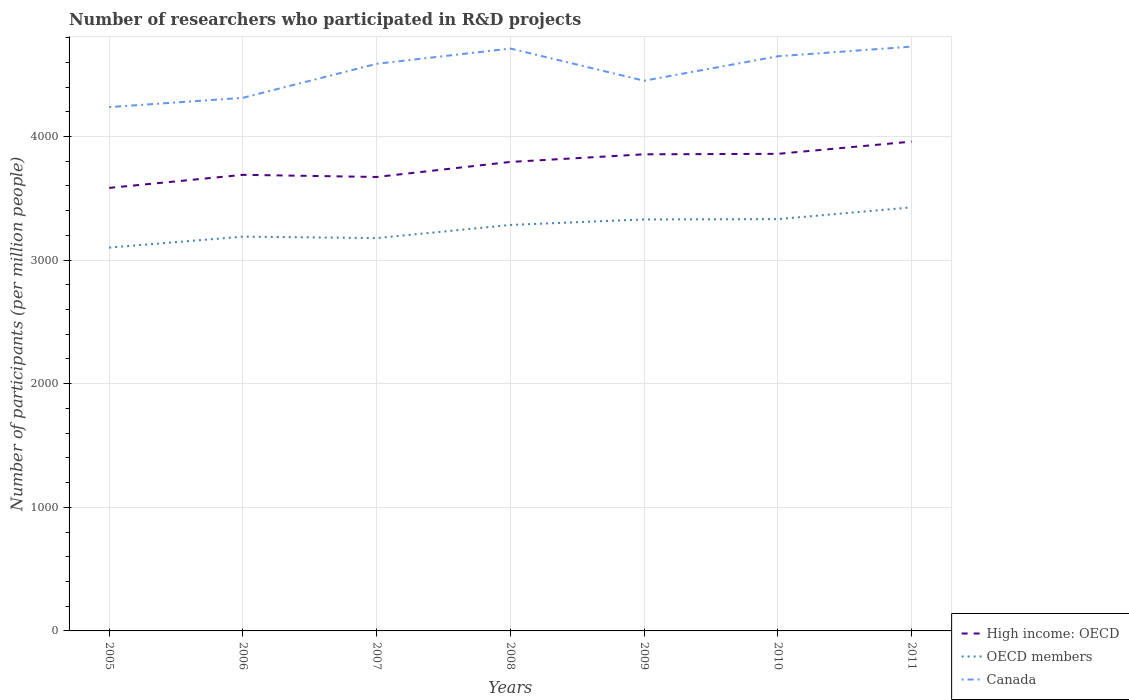How many different coloured lines are there?
Offer a very short reply. 3. Across all years, what is the maximum number of researchers who participated in R&D projects in High income: OECD?
Your answer should be very brief. 3584.25. What is the total number of researchers who participated in R&D projects in Canada in the graph?
Provide a succinct answer. -275.01. What is the difference between the highest and the second highest number of researchers who participated in R&D projects in High income: OECD?
Offer a very short reply. 374.47. What is the difference between the highest and the lowest number of researchers who participated in R&D projects in High income: OECD?
Ensure brevity in your answer.  4. Is the number of researchers who participated in R&D projects in High income: OECD strictly greater than the number of researchers who participated in R&D projects in OECD members over the years?
Provide a succinct answer. No. How many lines are there?
Provide a succinct answer. 3. Does the graph contain any zero values?
Keep it short and to the point. No. Does the graph contain grids?
Your answer should be very brief. Yes. Where does the legend appear in the graph?
Offer a very short reply. Bottom right. How many legend labels are there?
Keep it short and to the point. 3. How are the legend labels stacked?
Give a very brief answer. Vertical. What is the title of the graph?
Give a very brief answer. Number of researchers who participated in R&D projects. What is the label or title of the X-axis?
Make the answer very short. Years. What is the label or title of the Y-axis?
Your answer should be compact. Number of participants (per million people). What is the Number of participants (per million people) in High income: OECD in 2005?
Keep it short and to the point. 3584.25. What is the Number of participants (per million people) of OECD members in 2005?
Provide a short and direct response. 3101.32. What is the Number of participants (per million people) in Canada in 2005?
Provide a short and direct response. 4237.93. What is the Number of participants (per million people) in High income: OECD in 2006?
Your response must be concise. 3690.04. What is the Number of participants (per million people) of OECD members in 2006?
Your answer should be very brief. 3189.88. What is the Number of participants (per million people) of Canada in 2006?
Provide a short and direct response. 4313.21. What is the Number of participants (per million people) of High income: OECD in 2007?
Provide a short and direct response. 3672.63. What is the Number of participants (per million people) of OECD members in 2007?
Give a very brief answer. 3178.1. What is the Number of participants (per million people) of Canada in 2007?
Keep it short and to the point. 4588.22. What is the Number of participants (per million people) of High income: OECD in 2008?
Provide a succinct answer. 3794.36. What is the Number of participants (per million people) of OECD members in 2008?
Ensure brevity in your answer.  3284.49. What is the Number of participants (per million people) in Canada in 2008?
Ensure brevity in your answer.  4711.77. What is the Number of participants (per million people) of High income: OECD in 2009?
Offer a very short reply. 3856. What is the Number of participants (per million people) of OECD members in 2009?
Give a very brief answer. 3329.07. What is the Number of participants (per million people) in Canada in 2009?
Give a very brief answer. 4451.42. What is the Number of participants (per million people) of High income: OECD in 2010?
Offer a very short reply. 3859.78. What is the Number of participants (per million people) in OECD members in 2010?
Give a very brief answer. 3331.63. What is the Number of participants (per million people) of Canada in 2010?
Ensure brevity in your answer.  4649.22. What is the Number of participants (per million people) in High income: OECD in 2011?
Your answer should be compact. 3958.72. What is the Number of participants (per million people) of OECD members in 2011?
Provide a short and direct response. 3426.85. What is the Number of participants (per million people) of Canada in 2011?
Provide a short and direct response. 4727.26. Across all years, what is the maximum Number of participants (per million people) in High income: OECD?
Keep it short and to the point. 3958.72. Across all years, what is the maximum Number of participants (per million people) of OECD members?
Keep it short and to the point. 3426.85. Across all years, what is the maximum Number of participants (per million people) of Canada?
Your response must be concise. 4727.26. Across all years, what is the minimum Number of participants (per million people) of High income: OECD?
Your response must be concise. 3584.25. Across all years, what is the minimum Number of participants (per million people) in OECD members?
Your response must be concise. 3101.32. Across all years, what is the minimum Number of participants (per million people) of Canada?
Provide a succinct answer. 4237.93. What is the total Number of participants (per million people) in High income: OECD in the graph?
Ensure brevity in your answer.  2.64e+04. What is the total Number of participants (per million people) in OECD members in the graph?
Offer a very short reply. 2.28e+04. What is the total Number of participants (per million people) in Canada in the graph?
Keep it short and to the point. 3.17e+04. What is the difference between the Number of participants (per million people) of High income: OECD in 2005 and that in 2006?
Ensure brevity in your answer.  -105.79. What is the difference between the Number of participants (per million people) in OECD members in 2005 and that in 2006?
Ensure brevity in your answer.  -88.56. What is the difference between the Number of participants (per million people) in Canada in 2005 and that in 2006?
Ensure brevity in your answer.  -75.28. What is the difference between the Number of participants (per million people) of High income: OECD in 2005 and that in 2007?
Offer a terse response. -88.38. What is the difference between the Number of participants (per million people) in OECD members in 2005 and that in 2007?
Give a very brief answer. -76.77. What is the difference between the Number of participants (per million people) in Canada in 2005 and that in 2007?
Your response must be concise. -350.29. What is the difference between the Number of participants (per million people) in High income: OECD in 2005 and that in 2008?
Give a very brief answer. -210.11. What is the difference between the Number of participants (per million people) of OECD members in 2005 and that in 2008?
Ensure brevity in your answer.  -183.16. What is the difference between the Number of participants (per million people) of Canada in 2005 and that in 2008?
Offer a very short reply. -473.84. What is the difference between the Number of participants (per million people) of High income: OECD in 2005 and that in 2009?
Give a very brief answer. -271.75. What is the difference between the Number of participants (per million people) of OECD members in 2005 and that in 2009?
Offer a very short reply. -227.74. What is the difference between the Number of participants (per million people) in Canada in 2005 and that in 2009?
Your answer should be compact. -213.49. What is the difference between the Number of participants (per million people) in High income: OECD in 2005 and that in 2010?
Provide a short and direct response. -275.53. What is the difference between the Number of participants (per million people) in OECD members in 2005 and that in 2010?
Make the answer very short. -230.3. What is the difference between the Number of participants (per million people) in Canada in 2005 and that in 2010?
Make the answer very short. -411.29. What is the difference between the Number of participants (per million people) of High income: OECD in 2005 and that in 2011?
Your answer should be very brief. -374.47. What is the difference between the Number of participants (per million people) of OECD members in 2005 and that in 2011?
Keep it short and to the point. -325.53. What is the difference between the Number of participants (per million people) of Canada in 2005 and that in 2011?
Provide a short and direct response. -489.33. What is the difference between the Number of participants (per million people) in High income: OECD in 2006 and that in 2007?
Make the answer very short. 17.41. What is the difference between the Number of participants (per million people) of OECD members in 2006 and that in 2007?
Provide a succinct answer. 11.78. What is the difference between the Number of participants (per million people) of Canada in 2006 and that in 2007?
Give a very brief answer. -275.01. What is the difference between the Number of participants (per million people) in High income: OECD in 2006 and that in 2008?
Give a very brief answer. -104.32. What is the difference between the Number of participants (per million people) of OECD members in 2006 and that in 2008?
Make the answer very short. -94.6. What is the difference between the Number of participants (per million people) in Canada in 2006 and that in 2008?
Ensure brevity in your answer.  -398.56. What is the difference between the Number of participants (per million people) of High income: OECD in 2006 and that in 2009?
Give a very brief answer. -165.96. What is the difference between the Number of participants (per million people) in OECD members in 2006 and that in 2009?
Offer a very short reply. -139.18. What is the difference between the Number of participants (per million people) of Canada in 2006 and that in 2009?
Ensure brevity in your answer.  -138.21. What is the difference between the Number of participants (per million people) in High income: OECD in 2006 and that in 2010?
Provide a short and direct response. -169.74. What is the difference between the Number of participants (per million people) in OECD members in 2006 and that in 2010?
Offer a very short reply. -141.75. What is the difference between the Number of participants (per million people) in Canada in 2006 and that in 2010?
Your answer should be very brief. -336.01. What is the difference between the Number of participants (per million people) of High income: OECD in 2006 and that in 2011?
Your answer should be compact. -268.68. What is the difference between the Number of participants (per million people) of OECD members in 2006 and that in 2011?
Provide a succinct answer. -236.97. What is the difference between the Number of participants (per million people) of Canada in 2006 and that in 2011?
Your response must be concise. -414.05. What is the difference between the Number of participants (per million people) in High income: OECD in 2007 and that in 2008?
Give a very brief answer. -121.73. What is the difference between the Number of participants (per million people) in OECD members in 2007 and that in 2008?
Provide a succinct answer. -106.39. What is the difference between the Number of participants (per million people) of Canada in 2007 and that in 2008?
Ensure brevity in your answer.  -123.55. What is the difference between the Number of participants (per million people) of High income: OECD in 2007 and that in 2009?
Provide a short and direct response. -183.37. What is the difference between the Number of participants (per million people) in OECD members in 2007 and that in 2009?
Offer a terse response. -150.97. What is the difference between the Number of participants (per million people) in Canada in 2007 and that in 2009?
Your response must be concise. 136.81. What is the difference between the Number of participants (per million people) of High income: OECD in 2007 and that in 2010?
Your answer should be compact. -187.15. What is the difference between the Number of participants (per million people) in OECD members in 2007 and that in 2010?
Offer a terse response. -153.53. What is the difference between the Number of participants (per million people) in Canada in 2007 and that in 2010?
Give a very brief answer. -61. What is the difference between the Number of participants (per million people) in High income: OECD in 2007 and that in 2011?
Provide a succinct answer. -286.09. What is the difference between the Number of participants (per million people) in OECD members in 2007 and that in 2011?
Provide a succinct answer. -248.75. What is the difference between the Number of participants (per million people) in Canada in 2007 and that in 2011?
Give a very brief answer. -139.04. What is the difference between the Number of participants (per million people) in High income: OECD in 2008 and that in 2009?
Offer a very short reply. -61.64. What is the difference between the Number of participants (per million people) of OECD members in 2008 and that in 2009?
Ensure brevity in your answer.  -44.58. What is the difference between the Number of participants (per million people) in Canada in 2008 and that in 2009?
Your response must be concise. 260.35. What is the difference between the Number of participants (per million people) of High income: OECD in 2008 and that in 2010?
Your answer should be very brief. -65.42. What is the difference between the Number of participants (per million people) of OECD members in 2008 and that in 2010?
Your answer should be very brief. -47.14. What is the difference between the Number of participants (per million people) in Canada in 2008 and that in 2010?
Offer a very short reply. 62.55. What is the difference between the Number of participants (per million people) in High income: OECD in 2008 and that in 2011?
Offer a terse response. -164.36. What is the difference between the Number of participants (per million people) of OECD members in 2008 and that in 2011?
Offer a very short reply. -142.36. What is the difference between the Number of participants (per million people) in Canada in 2008 and that in 2011?
Ensure brevity in your answer.  -15.49. What is the difference between the Number of participants (per million people) of High income: OECD in 2009 and that in 2010?
Ensure brevity in your answer.  -3.78. What is the difference between the Number of participants (per million people) in OECD members in 2009 and that in 2010?
Provide a succinct answer. -2.56. What is the difference between the Number of participants (per million people) of Canada in 2009 and that in 2010?
Offer a terse response. -197.8. What is the difference between the Number of participants (per million people) in High income: OECD in 2009 and that in 2011?
Provide a succinct answer. -102.72. What is the difference between the Number of participants (per million people) of OECD members in 2009 and that in 2011?
Your answer should be compact. -97.79. What is the difference between the Number of participants (per million people) of Canada in 2009 and that in 2011?
Your answer should be compact. -275.84. What is the difference between the Number of participants (per million people) in High income: OECD in 2010 and that in 2011?
Ensure brevity in your answer.  -98.94. What is the difference between the Number of participants (per million people) in OECD members in 2010 and that in 2011?
Give a very brief answer. -95.22. What is the difference between the Number of participants (per million people) of Canada in 2010 and that in 2011?
Provide a short and direct response. -78.04. What is the difference between the Number of participants (per million people) in High income: OECD in 2005 and the Number of participants (per million people) in OECD members in 2006?
Your answer should be very brief. 394.37. What is the difference between the Number of participants (per million people) of High income: OECD in 2005 and the Number of participants (per million people) of Canada in 2006?
Offer a very short reply. -728.96. What is the difference between the Number of participants (per million people) of OECD members in 2005 and the Number of participants (per million people) of Canada in 2006?
Give a very brief answer. -1211.89. What is the difference between the Number of participants (per million people) of High income: OECD in 2005 and the Number of participants (per million people) of OECD members in 2007?
Your answer should be compact. 406.15. What is the difference between the Number of participants (per million people) in High income: OECD in 2005 and the Number of participants (per million people) in Canada in 2007?
Provide a short and direct response. -1003.97. What is the difference between the Number of participants (per million people) in OECD members in 2005 and the Number of participants (per million people) in Canada in 2007?
Offer a terse response. -1486.9. What is the difference between the Number of participants (per million people) in High income: OECD in 2005 and the Number of participants (per million people) in OECD members in 2008?
Ensure brevity in your answer.  299.76. What is the difference between the Number of participants (per million people) of High income: OECD in 2005 and the Number of participants (per million people) of Canada in 2008?
Provide a short and direct response. -1127.52. What is the difference between the Number of participants (per million people) of OECD members in 2005 and the Number of participants (per million people) of Canada in 2008?
Your answer should be very brief. -1610.45. What is the difference between the Number of participants (per million people) of High income: OECD in 2005 and the Number of participants (per million people) of OECD members in 2009?
Keep it short and to the point. 255.18. What is the difference between the Number of participants (per million people) of High income: OECD in 2005 and the Number of participants (per million people) of Canada in 2009?
Ensure brevity in your answer.  -867.17. What is the difference between the Number of participants (per million people) in OECD members in 2005 and the Number of participants (per million people) in Canada in 2009?
Offer a terse response. -1350.09. What is the difference between the Number of participants (per million people) of High income: OECD in 2005 and the Number of participants (per million people) of OECD members in 2010?
Provide a short and direct response. 252.62. What is the difference between the Number of participants (per million people) in High income: OECD in 2005 and the Number of participants (per million people) in Canada in 2010?
Give a very brief answer. -1064.97. What is the difference between the Number of participants (per million people) of OECD members in 2005 and the Number of participants (per million people) of Canada in 2010?
Your answer should be compact. -1547.89. What is the difference between the Number of participants (per million people) of High income: OECD in 2005 and the Number of participants (per million people) of OECD members in 2011?
Ensure brevity in your answer.  157.4. What is the difference between the Number of participants (per million people) of High income: OECD in 2005 and the Number of participants (per million people) of Canada in 2011?
Your response must be concise. -1143.01. What is the difference between the Number of participants (per million people) in OECD members in 2005 and the Number of participants (per million people) in Canada in 2011?
Give a very brief answer. -1625.94. What is the difference between the Number of participants (per million people) of High income: OECD in 2006 and the Number of participants (per million people) of OECD members in 2007?
Provide a succinct answer. 511.94. What is the difference between the Number of participants (per million people) of High income: OECD in 2006 and the Number of participants (per million people) of Canada in 2007?
Your answer should be compact. -898.18. What is the difference between the Number of participants (per million people) in OECD members in 2006 and the Number of participants (per million people) in Canada in 2007?
Keep it short and to the point. -1398.34. What is the difference between the Number of participants (per million people) in High income: OECD in 2006 and the Number of participants (per million people) in OECD members in 2008?
Provide a succinct answer. 405.55. What is the difference between the Number of participants (per million people) in High income: OECD in 2006 and the Number of participants (per million people) in Canada in 2008?
Keep it short and to the point. -1021.73. What is the difference between the Number of participants (per million people) of OECD members in 2006 and the Number of participants (per million people) of Canada in 2008?
Your answer should be compact. -1521.89. What is the difference between the Number of participants (per million people) of High income: OECD in 2006 and the Number of participants (per million people) of OECD members in 2009?
Provide a short and direct response. 360.98. What is the difference between the Number of participants (per million people) in High income: OECD in 2006 and the Number of participants (per million people) in Canada in 2009?
Make the answer very short. -761.37. What is the difference between the Number of participants (per million people) of OECD members in 2006 and the Number of participants (per million people) of Canada in 2009?
Provide a short and direct response. -1261.53. What is the difference between the Number of participants (per million people) of High income: OECD in 2006 and the Number of participants (per million people) of OECD members in 2010?
Give a very brief answer. 358.41. What is the difference between the Number of participants (per million people) in High income: OECD in 2006 and the Number of participants (per million people) in Canada in 2010?
Provide a succinct answer. -959.18. What is the difference between the Number of participants (per million people) in OECD members in 2006 and the Number of participants (per million people) in Canada in 2010?
Ensure brevity in your answer.  -1459.33. What is the difference between the Number of participants (per million people) of High income: OECD in 2006 and the Number of participants (per million people) of OECD members in 2011?
Your response must be concise. 263.19. What is the difference between the Number of participants (per million people) in High income: OECD in 2006 and the Number of participants (per million people) in Canada in 2011?
Your answer should be compact. -1037.22. What is the difference between the Number of participants (per million people) in OECD members in 2006 and the Number of participants (per million people) in Canada in 2011?
Provide a short and direct response. -1537.38. What is the difference between the Number of participants (per million people) in High income: OECD in 2007 and the Number of participants (per million people) in OECD members in 2008?
Offer a terse response. 388.15. What is the difference between the Number of participants (per million people) in High income: OECD in 2007 and the Number of participants (per million people) in Canada in 2008?
Offer a very short reply. -1039.14. What is the difference between the Number of participants (per million people) of OECD members in 2007 and the Number of participants (per million people) of Canada in 2008?
Keep it short and to the point. -1533.67. What is the difference between the Number of participants (per million people) of High income: OECD in 2007 and the Number of participants (per million people) of OECD members in 2009?
Make the answer very short. 343.57. What is the difference between the Number of participants (per million people) in High income: OECD in 2007 and the Number of participants (per million people) in Canada in 2009?
Ensure brevity in your answer.  -778.78. What is the difference between the Number of participants (per million people) in OECD members in 2007 and the Number of participants (per million people) in Canada in 2009?
Your answer should be compact. -1273.32. What is the difference between the Number of participants (per million people) in High income: OECD in 2007 and the Number of participants (per million people) in OECD members in 2010?
Offer a terse response. 341. What is the difference between the Number of participants (per million people) of High income: OECD in 2007 and the Number of participants (per million people) of Canada in 2010?
Your answer should be very brief. -976.58. What is the difference between the Number of participants (per million people) of OECD members in 2007 and the Number of participants (per million people) of Canada in 2010?
Your response must be concise. -1471.12. What is the difference between the Number of participants (per million people) of High income: OECD in 2007 and the Number of participants (per million people) of OECD members in 2011?
Give a very brief answer. 245.78. What is the difference between the Number of participants (per million people) in High income: OECD in 2007 and the Number of participants (per million people) in Canada in 2011?
Provide a short and direct response. -1054.63. What is the difference between the Number of participants (per million people) in OECD members in 2007 and the Number of participants (per million people) in Canada in 2011?
Provide a short and direct response. -1549.16. What is the difference between the Number of participants (per million people) of High income: OECD in 2008 and the Number of participants (per million people) of OECD members in 2009?
Make the answer very short. 465.29. What is the difference between the Number of participants (per million people) in High income: OECD in 2008 and the Number of participants (per million people) in Canada in 2009?
Provide a short and direct response. -657.06. What is the difference between the Number of participants (per million people) of OECD members in 2008 and the Number of participants (per million people) of Canada in 2009?
Your answer should be very brief. -1166.93. What is the difference between the Number of participants (per million people) in High income: OECD in 2008 and the Number of participants (per million people) in OECD members in 2010?
Make the answer very short. 462.73. What is the difference between the Number of participants (per million people) in High income: OECD in 2008 and the Number of participants (per million people) in Canada in 2010?
Make the answer very short. -854.86. What is the difference between the Number of participants (per million people) of OECD members in 2008 and the Number of participants (per million people) of Canada in 2010?
Your response must be concise. -1364.73. What is the difference between the Number of participants (per million people) in High income: OECD in 2008 and the Number of participants (per million people) in OECD members in 2011?
Make the answer very short. 367.51. What is the difference between the Number of participants (per million people) of High income: OECD in 2008 and the Number of participants (per million people) of Canada in 2011?
Your response must be concise. -932.9. What is the difference between the Number of participants (per million people) of OECD members in 2008 and the Number of participants (per million people) of Canada in 2011?
Make the answer very short. -1442.77. What is the difference between the Number of participants (per million people) in High income: OECD in 2009 and the Number of participants (per million people) in OECD members in 2010?
Ensure brevity in your answer.  524.37. What is the difference between the Number of participants (per million people) of High income: OECD in 2009 and the Number of participants (per million people) of Canada in 2010?
Make the answer very short. -793.22. What is the difference between the Number of participants (per million people) of OECD members in 2009 and the Number of participants (per million people) of Canada in 2010?
Offer a very short reply. -1320.15. What is the difference between the Number of participants (per million people) of High income: OECD in 2009 and the Number of participants (per million people) of OECD members in 2011?
Provide a short and direct response. 429.15. What is the difference between the Number of participants (per million people) of High income: OECD in 2009 and the Number of participants (per million people) of Canada in 2011?
Keep it short and to the point. -871.26. What is the difference between the Number of participants (per million people) of OECD members in 2009 and the Number of participants (per million people) of Canada in 2011?
Provide a succinct answer. -1398.19. What is the difference between the Number of participants (per million people) of High income: OECD in 2010 and the Number of participants (per million people) of OECD members in 2011?
Your response must be concise. 432.93. What is the difference between the Number of participants (per million people) of High income: OECD in 2010 and the Number of participants (per million people) of Canada in 2011?
Give a very brief answer. -867.48. What is the difference between the Number of participants (per million people) in OECD members in 2010 and the Number of participants (per million people) in Canada in 2011?
Keep it short and to the point. -1395.63. What is the average Number of participants (per million people) of High income: OECD per year?
Offer a very short reply. 3773.68. What is the average Number of participants (per million people) of OECD members per year?
Offer a very short reply. 3263.05. What is the average Number of participants (per million people) of Canada per year?
Provide a succinct answer. 4525.57. In the year 2005, what is the difference between the Number of participants (per million people) of High income: OECD and Number of participants (per million people) of OECD members?
Give a very brief answer. 482.92. In the year 2005, what is the difference between the Number of participants (per million people) in High income: OECD and Number of participants (per million people) in Canada?
Make the answer very short. -653.68. In the year 2005, what is the difference between the Number of participants (per million people) in OECD members and Number of participants (per million people) in Canada?
Provide a short and direct response. -1136.6. In the year 2006, what is the difference between the Number of participants (per million people) of High income: OECD and Number of participants (per million people) of OECD members?
Make the answer very short. 500.16. In the year 2006, what is the difference between the Number of participants (per million people) of High income: OECD and Number of participants (per million people) of Canada?
Give a very brief answer. -623.17. In the year 2006, what is the difference between the Number of participants (per million people) of OECD members and Number of participants (per million people) of Canada?
Offer a very short reply. -1123.33. In the year 2007, what is the difference between the Number of participants (per million people) of High income: OECD and Number of participants (per million people) of OECD members?
Your answer should be very brief. 494.53. In the year 2007, what is the difference between the Number of participants (per million people) of High income: OECD and Number of participants (per million people) of Canada?
Your answer should be very brief. -915.59. In the year 2007, what is the difference between the Number of participants (per million people) of OECD members and Number of participants (per million people) of Canada?
Provide a short and direct response. -1410.12. In the year 2008, what is the difference between the Number of participants (per million people) of High income: OECD and Number of participants (per million people) of OECD members?
Your answer should be compact. 509.87. In the year 2008, what is the difference between the Number of participants (per million people) of High income: OECD and Number of participants (per million people) of Canada?
Provide a short and direct response. -917.41. In the year 2008, what is the difference between the Number of participants (per million people) of OECD members and Number of participants (per million people) of Canada?
Ensure brevity in your answer.  -1427.28. In the year 2009, what is the difference between the Number of participants (per million people) of High income: OECD and Number of participants (per million people) of OECD members?
Your response must be concise. 526.94. In the year 2009, what is the difference between the Number of participants (per million people) in High income: OECD and Number of participants (per million people) in Canada?
Provide a succinct answer. -595.42. In the year 2009, what is the difference between the Number of participants (per million people) of OECD members and Number of participants (per million people) of Canada?
Provide a short and direct response. -1122.35. In the year 2010, what is the difference between the Number of participants (per million people) of High income: OECD and Number of participants (per million people) of OECD members?
Make the answer very short. 528.15. In the year 2010, what is the difference between the Number of participants (per million people) in High income: OECD and Number of participants (per million people) in Canada?
Provide a short and direct response. -789.44. In the year 2010, what is the difference between the Number of participants (per million people) in OECD members and Number of participants (per million people) in Canada?
Make the answer very short. -1317.59. In the year 2011, what is the difference between the Number of participants (per million people) in High income: OECD and Number of participants (per million people) in OECD members?
Offer a very short reply. 531.87. In the year 2011, what is the difference between the Number of participants (per million people) in High income: OECD and Number of participants (per million people) in Canada?
Give a very brief answer. -768.54. In the year 2011, what is the difference between the Number of participants (per million people) of OECD members and Number of participants (per million people) of Canada?
Your response must be concise. -1300.41. What is the ratio of the Number of participants (per million people) in High income: OECD in 2005 to that in 2006?
Your response must be concise. 0.97. What is the ratio of the Number of participants (per million people) of OECD members in 2005 to that in 2006?
Provide a succinct answer. 0.97. What is the ratio of the Number of participants (per million people) in Canada in 2005 to that in 2006?
Your answer should be very brief. 0.98. What is the ratio of the Number of participants (per million people) of High income: OECD in 2005 to that in 2007?
Give a very brief answer. 0.98. What is the ratio of the Number of participants (per million people) of OECD members in 2005 to that in 2007?
Your answer should be compact. 0.98. What is the ratio of the Number of participants (per million people) of Canada in 2005 to that in 2007?
Provide a succinct answer. 0.92. What is the ratio of the Number of participants (per million people) in High income: OECD in 2005 to that in 2008?
Offer a very short reply. 0.94. What is the ratio of the Number of participants (per million people) of OECD members in 2005 to that in 2008?
Ensure brevity in your answer.  0.94. What is the ratio of the Number of participants (per million people) of Canada in 2005 to that in 2008?
Keep it short and to the point. 0.9. What is the ratio of the Number of participants (per million people) in High income: OECD in 2005 to that in 2009?
Keep it short and to the point. 0.93. What is the ratio of the Number of participants (per million people) in OECD members in 2005 to that in 2009?
Your response must be concise. 0.93. What is the ratio of the Number of participants (per million people) in High income: OECD in 2005 to that in 2010?
Offer a very short reply. 0.93. What is the ratio of the Number of participants (per million people) of OECD members in 2005 to that in 2010?
Keep it short and to the point. 0.93. What is the ratio of the Number of participants (per million people) of Canada in 2005 to that in 2010?
Provide a succinct answer. 0.91. What is the ratio of the Number of participants (per million people) of High income: OECD in 2005 to that in 2011?
Give a very brief answer. 0.91. What is the ratio of the Number of participants (per million people) of OECD members in 2005 to that in 2011?
Offer a very short reply. 0.91. What is the ratio of the Number of participants (per million people) in Canada in 2005 to that in 2011?
Ensure brevity in your answer.  0.9. What is the ratio of the Number of participants (per million people) in Canada in 2006 to that in 2007?
Provide a short and direct response. 0.94. What is the ratio of the Number of participants (per million people) in High income: OECD in 2006 to that in 2008?
Your answer should be very brief. 0.97. What is the ratio of the Number of participants (per million people) in OECD members in 2006 to that in 2008?
Make the answer very short. 0.97. What is the ratio of the Number of participants (per million people) of Canada in 2006 to that in 2008?
Offer a terse response. 0.92. What is the ratio of the Number of participants (per million people) of OECD members in 2006 to that in 2009?
Ensure brevity in your answer.  0.96. What is the ratio of the Number of participants (per million people) of Canada in 2006 to that in 2009?
Your answer should be very brief. 0.97. What is the ratio of the Number of participants (per million people) of High income: OECD in 2006 to that in 2010?
Offer a terse response. 0.96. What is the ratio of the Number of participants (per million people) in OECD members in 2006 to that in 2010?
Provide a succinct answer. 0.96. What is the ratio of the Number of participants (per million people) of Canada in 2006 to that in 2010?
Keep it short and to the point. 0.93. What is the ratio of the Number of participants (per million people) of High income: OECD in 2006 to that in 2011?
Keep it short and to the point. 0.93. What is the ratio of the Number of participants (per million people) of OECD members in 2006 to that in 2011?
Provide a short and direct response. 0.93. What is the ratio of the Number of participants (per million people) of Canada in 2006 to that in 2011?
Your answer should be compact. 0.91. What is the ratio of the Number of participants (per million people) of High income: OECD in 2007 to that in 2008?
Offer a very short reply. 0.97. What is the ratio of the Number of participants (per million people) of OECD members in 2007 to that in 2008?
Give a very brief answer. 0.97. What is the ratio of the Number of participants (per million people) in Canada in 2007 to that in 2008?
Provide a succinct answer. 0.97. What is the ratio of the Number of participants (per million people) of OECD members in 2007 to that in 2009?
Make the answer very short. 0.95. What is the ratio of the Number of participants (per million people) in Canada in 2007 to that in 2009?
Keep it short and to the point. 1.03. What is the ratio of the Number of participants (per million people) in High income: OECD in 2007 to that in 2010?
Your response must be concise. 0.95. What is the ratio of the Number of participants (per million people) of OECD members in 2007 to that in 2010?
Provide a short and direct response. 0.95. What is the ratio of the Number of participants (per million people) in Canada in 2007 to that in 2010?
Give a very brief answer. 0.99. What is the ratio of the Number of participants (per million people) in High income: OECD in 2007 to that in 2011?
Keep it short and to the point. 0.93. What is the ratio of the Number of participants (per million people) of OECD members in 2007 to that in 2011?
Your response must be concise. 0.93. What is the ratio of the Number of participants (per million people) of Canada in 2007 to that in 2011?
Your answer should be compact. 0.97. What is the ratio of the Number of participants (per million people) in High income: OECD in 2008 to that in 2009?
Your answer should be compact. 0.98. What is the ratio of the Number of participants (per million people) in OECD members in 2008 to that in 2009?
Keep it short and to the point. 0.99. What is the ratio of the Number of participants (per million people) of Canada in 2008 to that in 2009?
Provide a short and direct response. 1.06. What is the ratio of the Number of participants (per million people) of High income: OECD in 2008 to that in 2010?
Your answer should be compact. 0.98. What is the ratio of the Number of participants (per million people) in OECD members in 2008 to that in 2010?
Give a very brief answer. 0.99. What is the ratio of the Number of participants (per million people) in Canada in 2008 to that in 2010?
Keep it short and to the point. 1.01. What is the ratio of the Number of participants (per million people) in High income: OECD in 2008 to that in 2011?
Offer a very short reply. 0.96. What is the ratio of the Number of participants (per million people) in OECD members in 2008 to that in 2011?
Offer a terse response. 0.96. What is the ratio of the Number of participants (per million people) in Canada in 2008 to that in 2011?
Make the answer very short. 1. What is the ratio of the Number of participants (per million people) of High income: OECD in 2009 to that in 2010?
Make the answer very short. 1. What is the ratio of the Number of participants (per million people) of OECD members in 2009 to that in 2010?
Make the answer very short. 1. What is the ratio of the Number of participants (per million people) of Canada in 2009 to that in 2010?
Make the answer very short. 0.96. What is the ratio of the Number of participants (per million people) in High income: OECD in 2009 to that in 2011?
Make the answer very short. 0.97. What is the ratio of the Number of participants (per million people) of OECD members in 2009 to that in 2011?
Ensure brevity in your answer.  0.97. What is the ratio of the Number of participants (per million people) of Canada in 2009 to that in 2011?
Keep it short and to the point. 0.94. What is the ratio of the Number of participants (per million people) of OECD members in 2010 to that in 2011?
Provide a succinct answer. 0.97. What is the ratio of the Number of participants (per million people) in Canada in 2010 to that in 2011?
Provide a succinct answer. 0.98. What is the difference between the highest and the second highest Number of participants (per million people) in High income: OECD?
Your response must be concise. 98.94. What is the difference between the highest and the second highest Number of participants (per million people) of OECD members?
Provide a succinct answer. 95.22. What is the difference between the highest and the second highest Number of participants (per million people) of Canada?
Provide a succinct answer. 15.49. What is the difference between the highest and the lowest Number of participants (per million people) of High income: OECD?
Offer a very short reply. 374.47. What is the difference between the highest and the lowest Number of participants (per million people) in OECD members?
Make the answer very short. 325.53. What is the difference between the highest and the lowest Number of participants (per million people) of Canada?
Your answer should be compact. 489.33. 